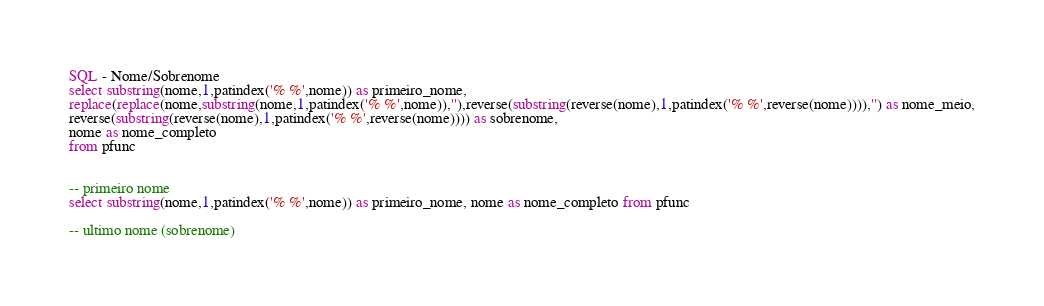<code> <loc_0><loc_0><loc_500><loc_500><_SQL_>SQL - Nome/Sobrenome
select substring(nome,1,patindex('% %',nome)) as primeiro_nome,
replace(replace(nome,substring(nome,1,patindex('% %',nome)),''),reverse(substring(reverse(nome),1,patindex('% %',reverse(nome)))),'') as nome_meio,
reverse(substring(reverse(nome),1,patindex('% %',reverse(nome)))) as sobrenome,
nome as nome_completo
from pfunc


-- primeiro nome
select substring(nome,1,patindex('% %',nome)) as primeiro_nome, nome as nome_completo from pfunc

-- ultimo nome (sobrenome)</code> 